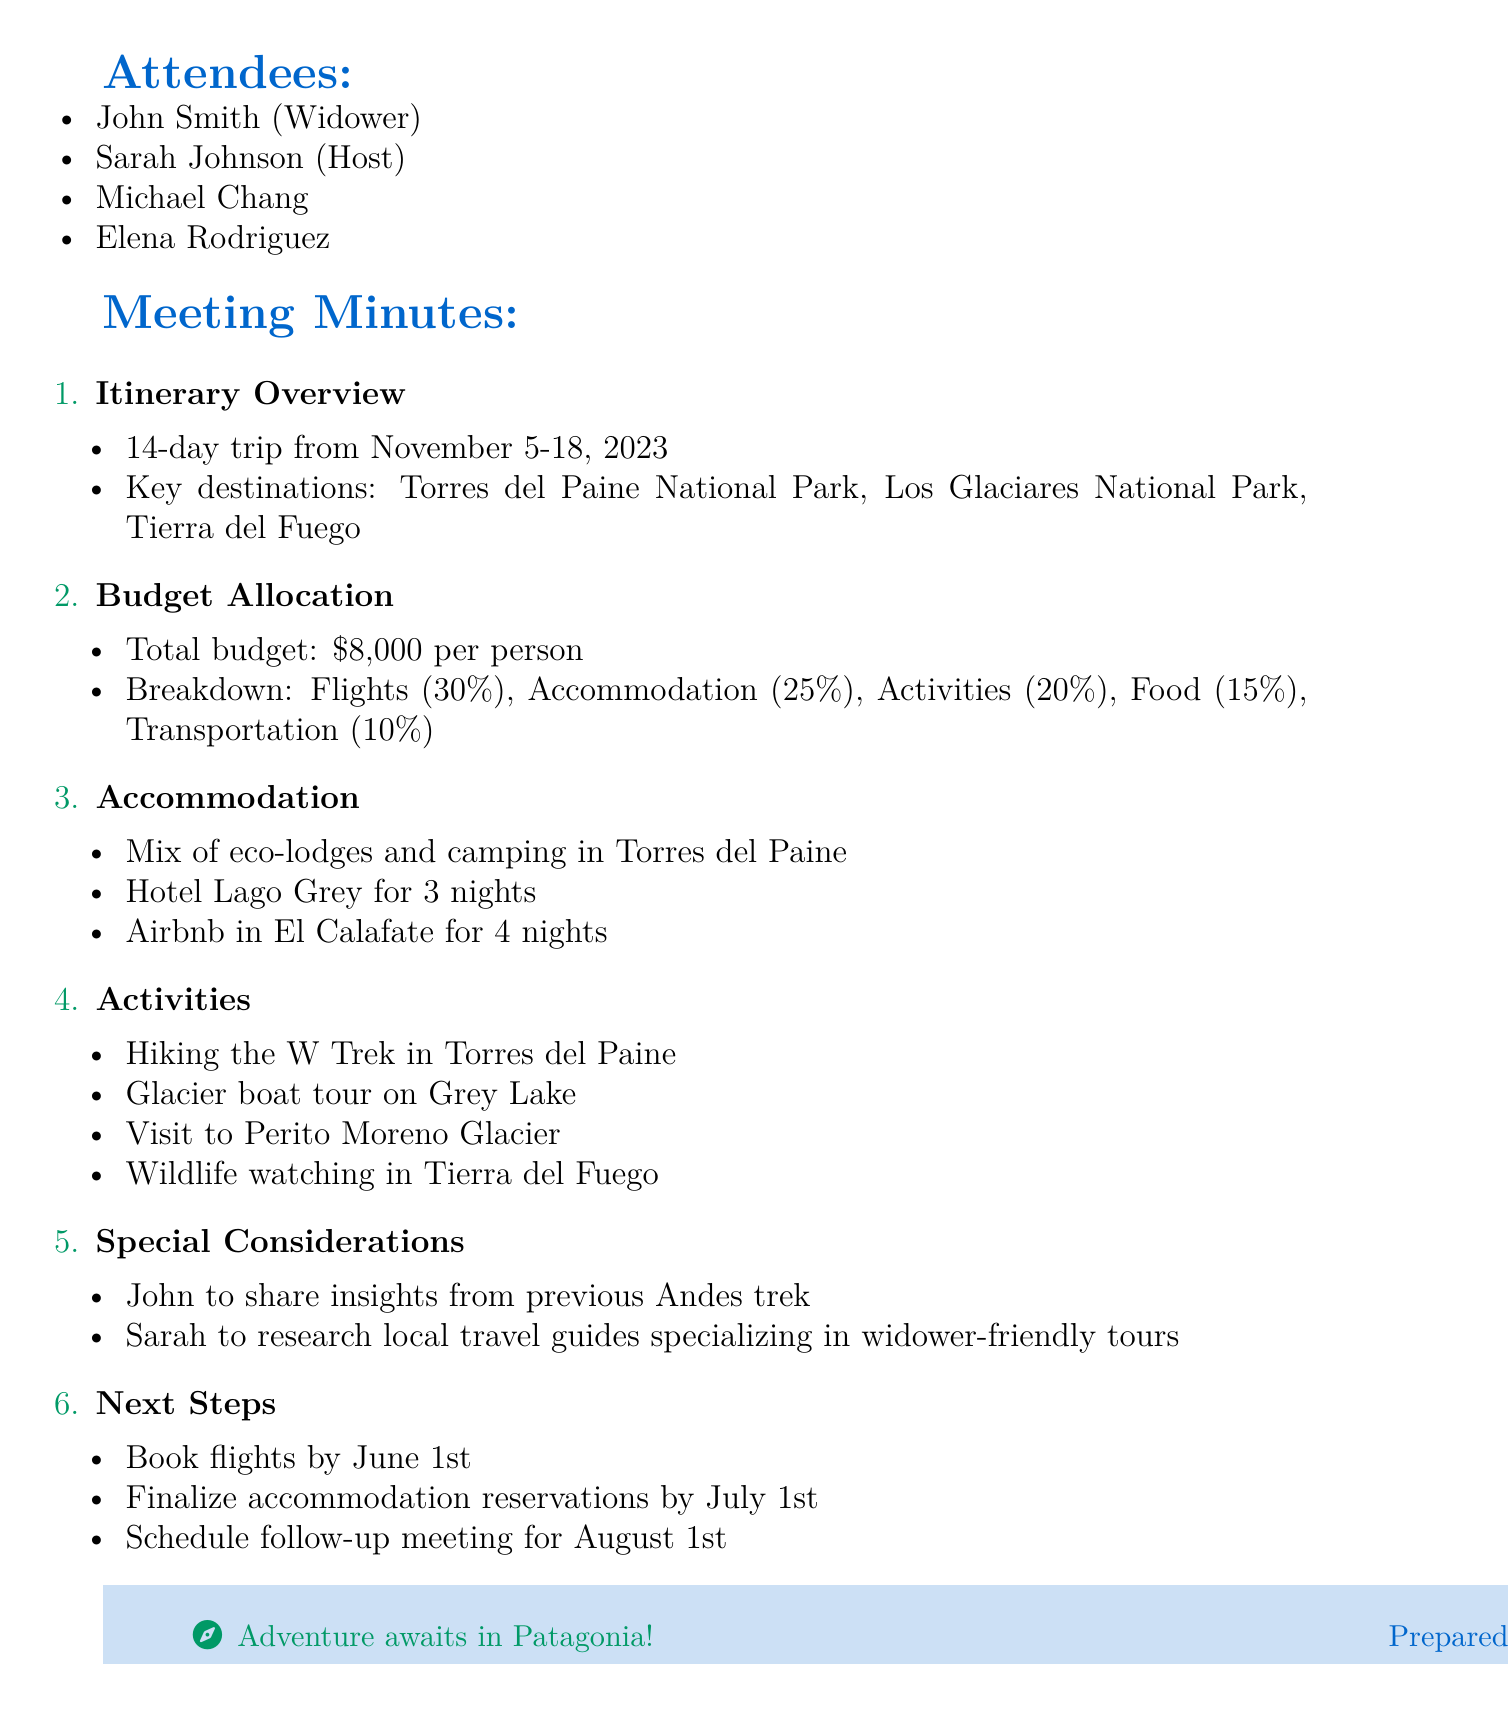What is the title of the meeting? The title is stated at the beginning of the document, which is "Patagonia Trip Planning."
Answer: Patagonia Trip Planning What are the key destinations mentioned in the itinerary? The document lists the key destinations as part of the itinerary overview: "Torres del Paine National Park, Los Glaciares National Park, Tierra del Fuego."
Answer: Torres del Paine National Park, Los Glaciares National Park, Tierra del Fuego What is the total budget per person for the trip? The total budget per person is explicitly mentioned in the budget allocation section as "$8,000."
Answer: $8,000 When is the trip scheduled to take place? The specific dates for the trip are provided in the itinerary section: "November 5-18, 2023."
Answer: November 5-18, 2023 Which hotel will the group stay at for 3 nights? The accommodation details specifically mention "Hotel Lago Grey" for 3 nights.
Answer: Hotel Lago Grey What activity is planned on Grey Lake? The document mentions a "Glacier boat tour on Grey Lake" as one of the planned activities.
Answer: Glacier boat tour on Grey Lake Who is responsible for researching local travel guides? The document states that "Sarah" will research local travel guides specializing in widower-friendly tours.
Answer: Sarah What is the deadline for booking flights? The next steps section specifies the deadline as "June 1st" for booking flights.
Answer: June 1st How many days is the trip planned for? The trip is detailed in the itinerary as being a "14-day trip."
Answer: 14-day trip 